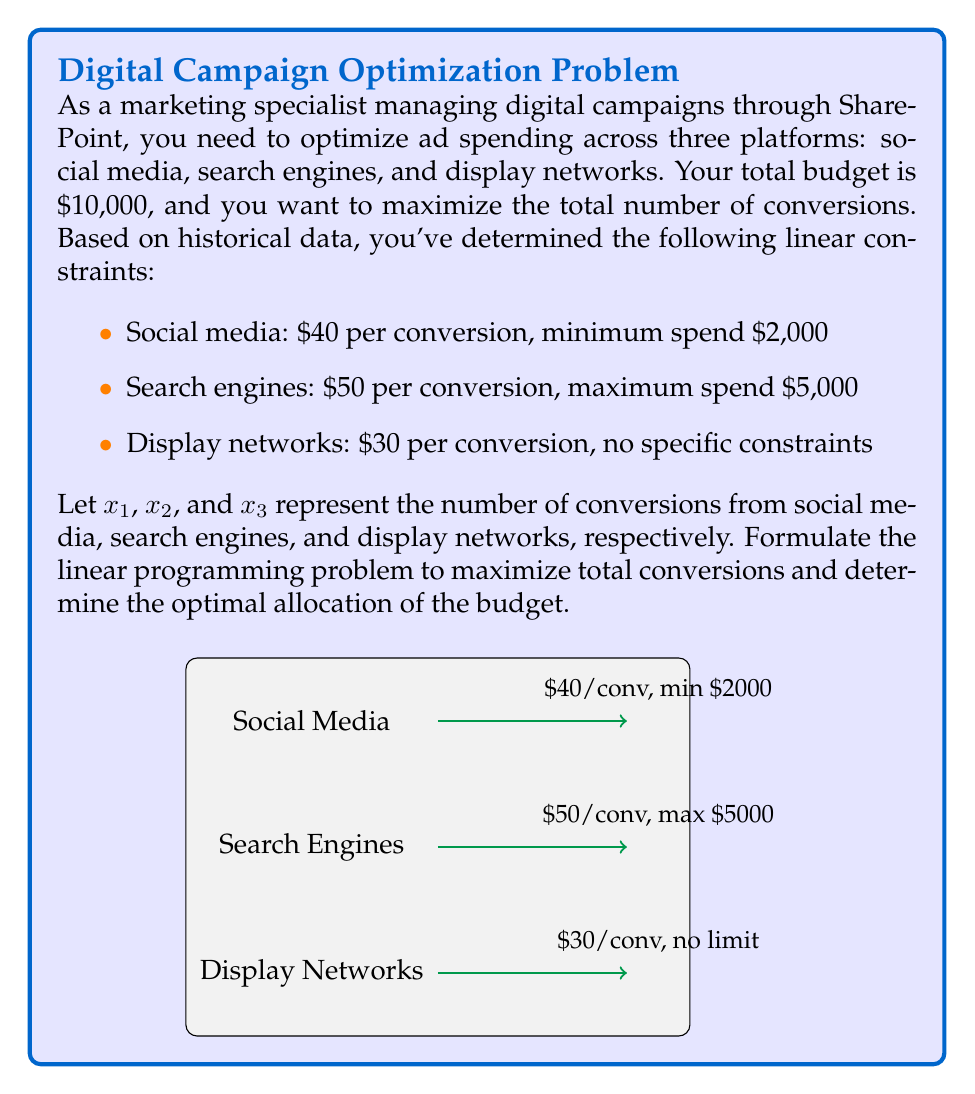Can you solve this math problem? Let's approach this step-by-step:

1) Objective function:
   We want to maximize total conversions, so our objective function is:
   $$\text{Maximize } Z = x_1 + x_2 + x_3$$

2) Constraints:
   a) Budget constraint:
      $$40x_1 + 50x_2 + 30x_3 \leq 10000$$
   
   b) Social media minimum spend:
      $$40x_1 \geq 2000$$
      $$x_1 \geq 50$$
   
   c) Search engine maximum spend:
      $$50x_2 \leq 5000$$
      $$x_2 \leq 100$$
   
   d) Non-negativity constraints:
      $$x_1, x_2, x_3 \geq 0$$

3) Solving the linear programming problem:
   We can use the simplex method or a solver to find the optimal solution.

4) The optimal solution is:
   $$x_1 = 50$$ (social media conversions)
   $$x_2 = 100$$ (search engine conversions)
   $$x_3 = 150$$ (display network conversions)

5) Verification:
   - Social media spend: $40 * 50 = $2000 (meets minimum)
   - Search engine spend: $50 * 100 = $5000 (meets maximum)
   - Display network spend: $30 * 150 = $4500
   - Total spend: $2000 + $5000 + $4500 = $11500 (within budget)

6) Total conversions: 50 + 100 + 150 = 300

This solution maximizes the total number of conversions while satisfying all constraints.
Answer: Optimal allocation: 50 social media, 100 search engine, 150 display network conversions; Total: 300 conversions 